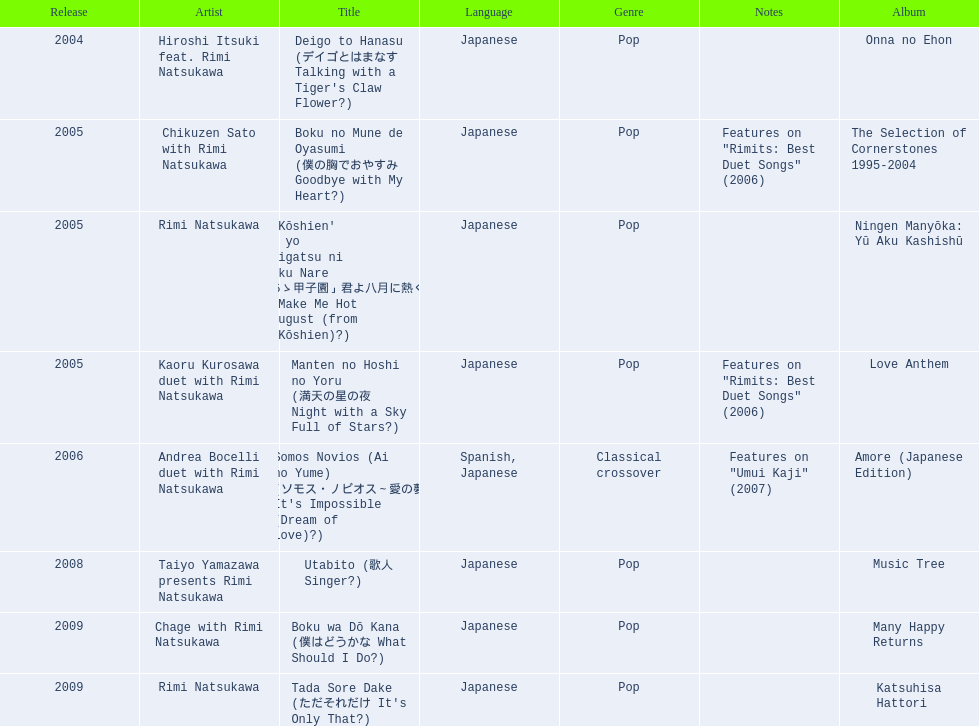What was the album released immediately before the one that had boku wa do kana on it? Music Tree. 